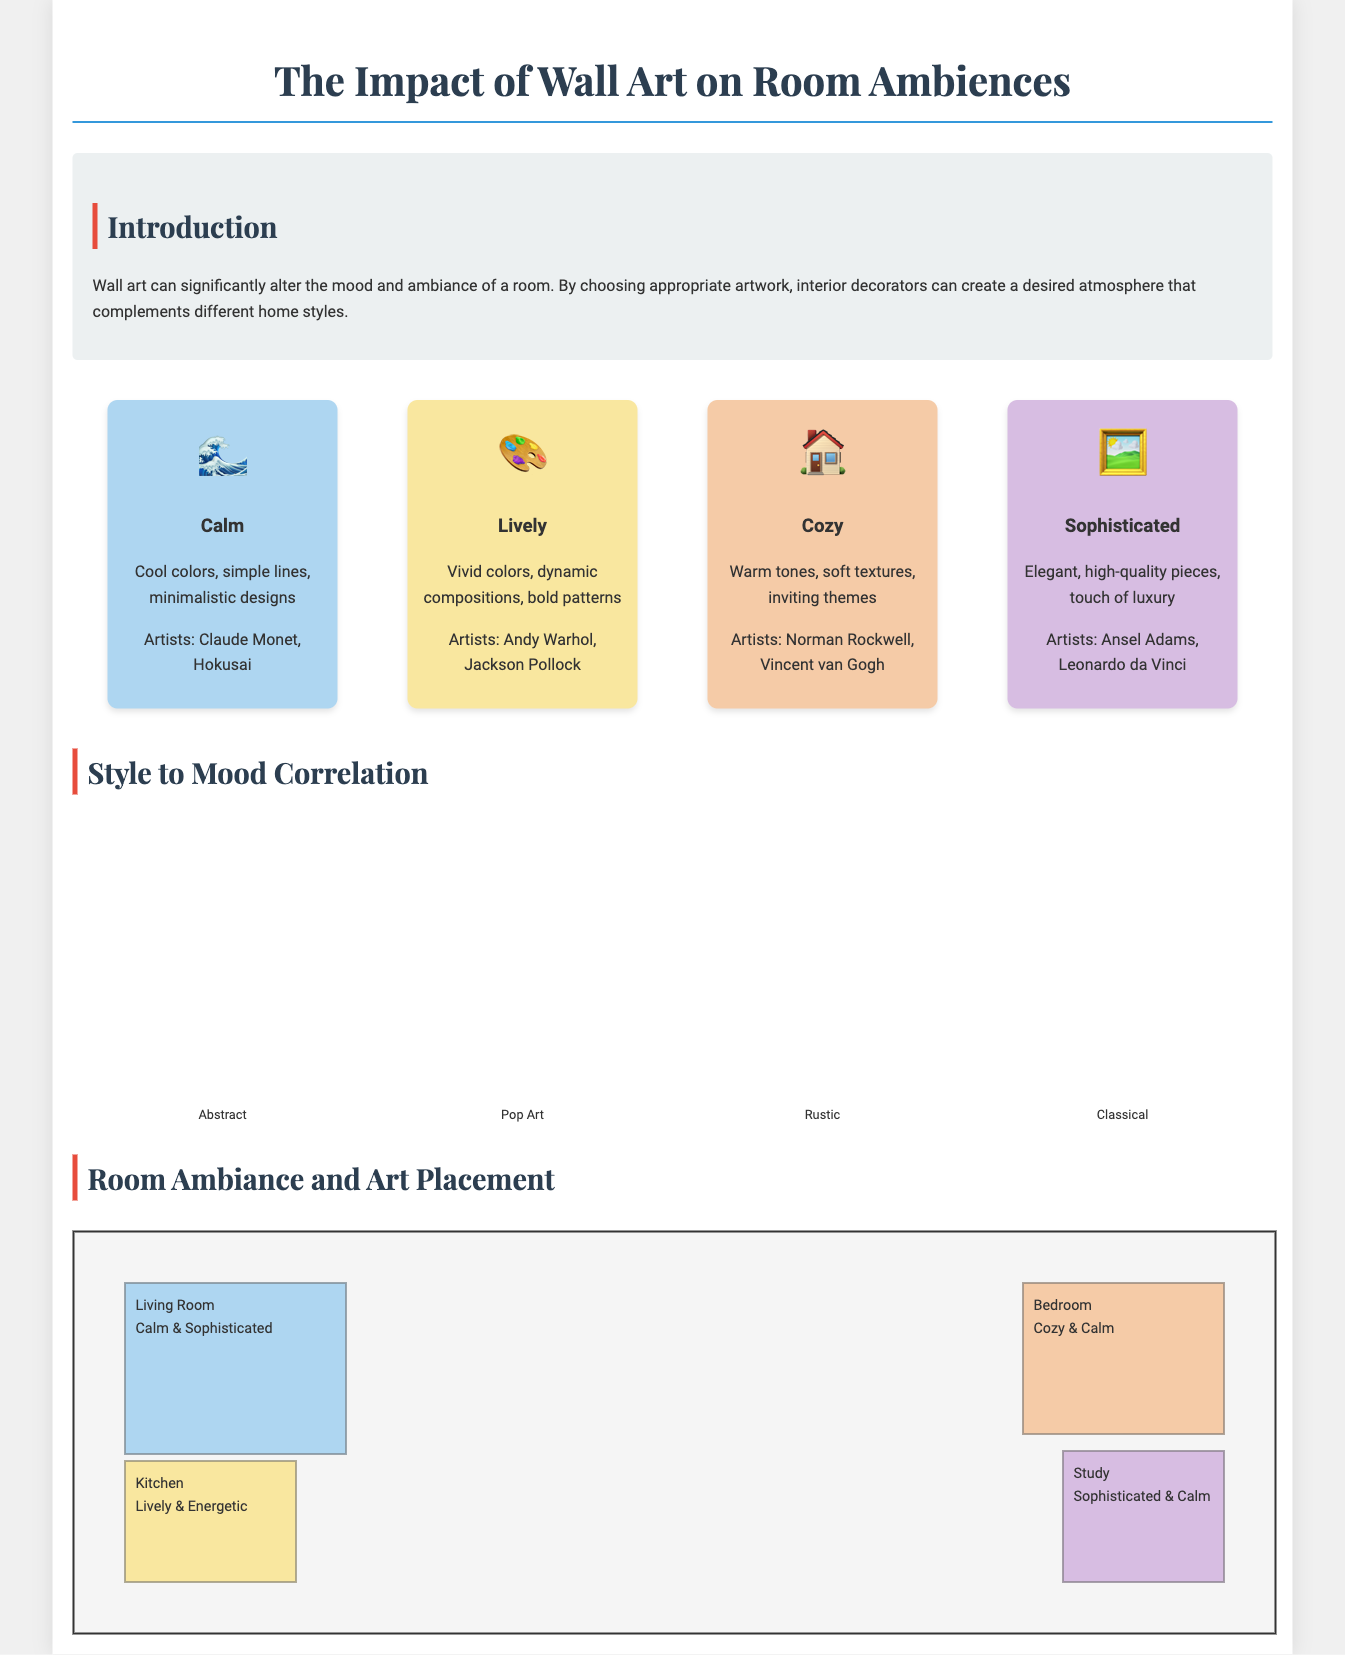What are the four moods represented in the infographics? The document lists four moods: Calm, Lively, Cozy, and Sophisticated.
Answer: Calm, Lively, Cozy, Sophisticated Which artist is associated with the Lively mood? The Lively mood is associated with artists such as Andy Warhol and Jackson Pollock.
Answer: Andy Warhol What percentage represents the height of the Pop Art bar in the style to mood correlation? The height of the Pop Art bar is represented at 90%.
Answer: 90% Which room is described as Calming and Sophisticated? The Living Room is described as Calm and Sophisticated in the room ambiance section.
Answer: Living Room What type of artwork is associated with the Cozy mood? The Cozy mood is associated with warm tones, soft textures, and inviting themes.
Answer: Warm tones, soft textures, inviting themes How many art styles are displayed in the style to mood correlation? There are four art styles displayed: Abstract, Pop Art, Rustic, and Classical.
Answer: Four Which mood is associated with the bedroom? The bedroom is associated with Cozy and Calm moods.
Answer: Cozy & Calm What is the main purpose of wall art according to the introduction? The main purpose of wall art is to alter the mood and ambiance of a room.
Answer: Alter the mood and ambiance of a room What color background represents the Cozy mood? The background color representing the Cozy mood is a warm color (#F5CBA7).
Answer: Warm color (#F5CBA7) 